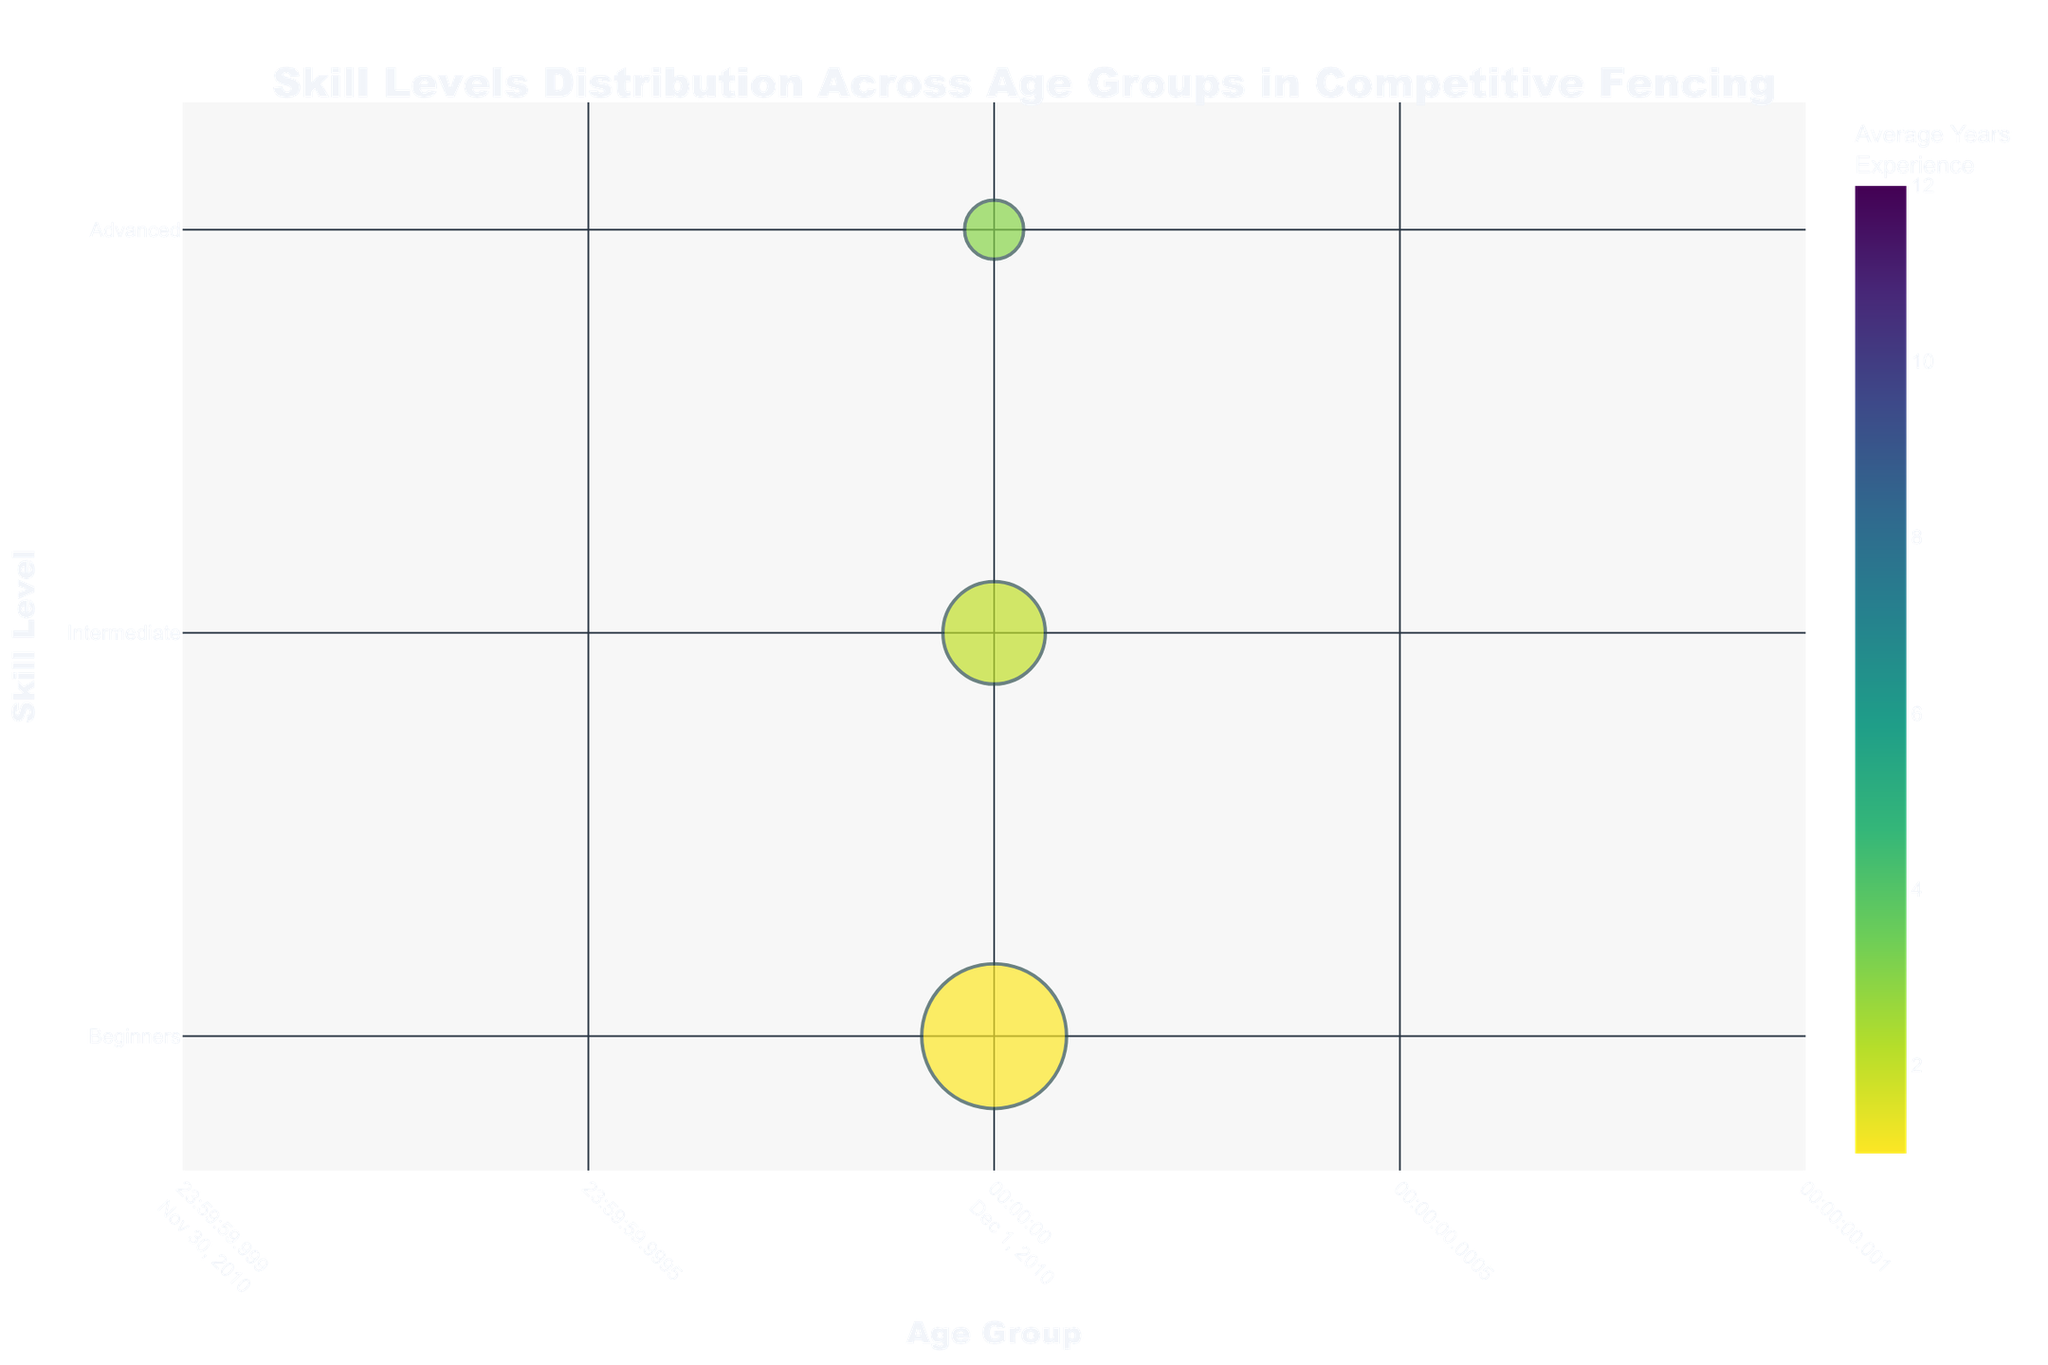What's the title of the figure? The title is located at the top center of the figure and it reads "Skill Levels Distribution Across Age Groups in Competitive Fencing".
Answer: Skill Levels Distribution Across Age Groups in Competitive Fencing How many fencers are in the 16-18 age group? By examining the size of the bubbles vertically aligned with the "16-18" label on the x-axis, the total number of fencers is the sum of all bubble sizes in this age group: Beginners (10), Intermediate (30), and Advanced (20).
Answer: 60 Which skill level has the highest number of fencers in the 23-30 age group? Looking at the bubbles in the "23-30" age group, the bubble for Intermediate skill level is the largest, therefore, it has the highest number of fencers.
Answer: Intermediate Which age group has the most Advanced fencers? By comparing the sizes of the bubbles at the Advanced skill level across all age groups, the "19-22" age group has the largest bubble for Advanced fencers.
Answer: 19-22 What's the average years of experience for Intermediate fencers in the 31-40 age group? The color of the Intermediate bubble in the "31-40" age group indicates the average years of experience. The color bar shows it corresponds to 6 years.
Answer: 6 How many age groups have fewer than 10 Beginners? By visually inspecting the size of the Beginners bubbles across all age groups, the "23-30", "31-40", and "41+" age groups each have fewer than 10 Beginners. Summing them up, there are 3 age groups.
Answer: 3 Which age group has the highest average years of experience for any skill level? Reviewing the colors of all bubbles across the age groups, the darkest color (highest average years of experience) is in the "41+" age group for Advanced skill level, which corresponds to 12 years.
Answer: 41+ What's the ratio of Intermediate to Advanced fencers in the 10-12 age group? The number of Intermediate fencers is 15 and the number of Advanced fencers is 5. Ratio is calculated as 15/5 = 3.
Answer: 3 Compare the number of Advanced fencers between the 13-15 and 16-18 age groups. Which has more or are they equal? The 13-15 group has 10 Advanced fencers, while the 16-18 group has 20. Comparing the two, the 16-18 group has more.
Answer: 16-18 How does the number of fencers change with skill level in the 41+ age group? In the 41+ age group, the number of fencers decreases from Beginners (1) to Intermediate (10) and further increases to Advanced (15).
Answer: Decreases then increases 